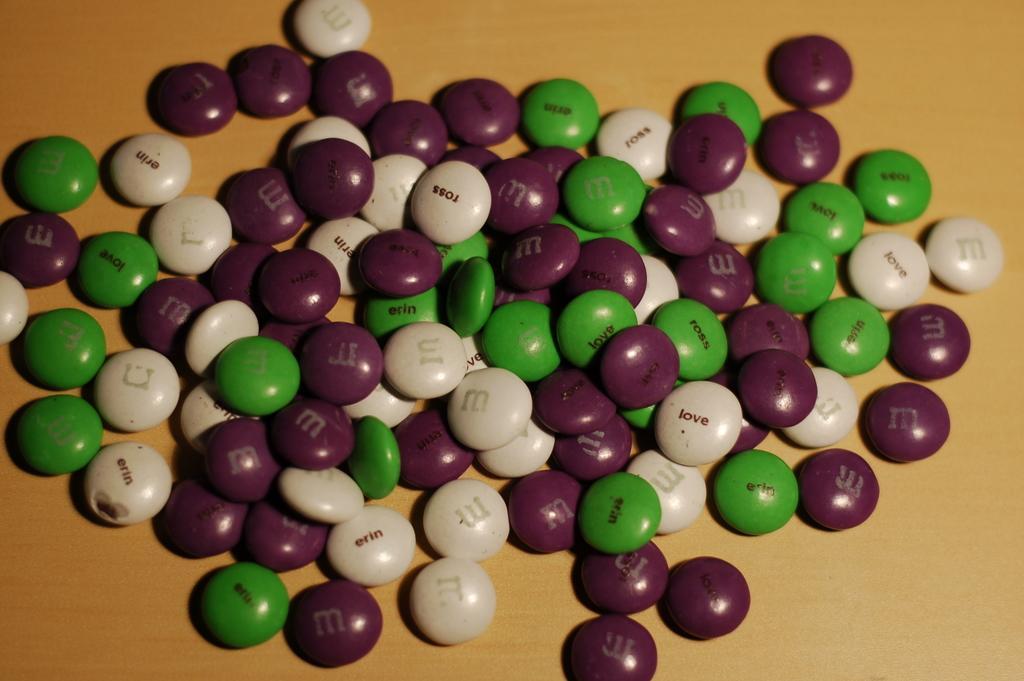Describe this image in one or two sentences. In this image I can see few m&ms which are green, cream and brown in color on the brown and cream colored surface. 